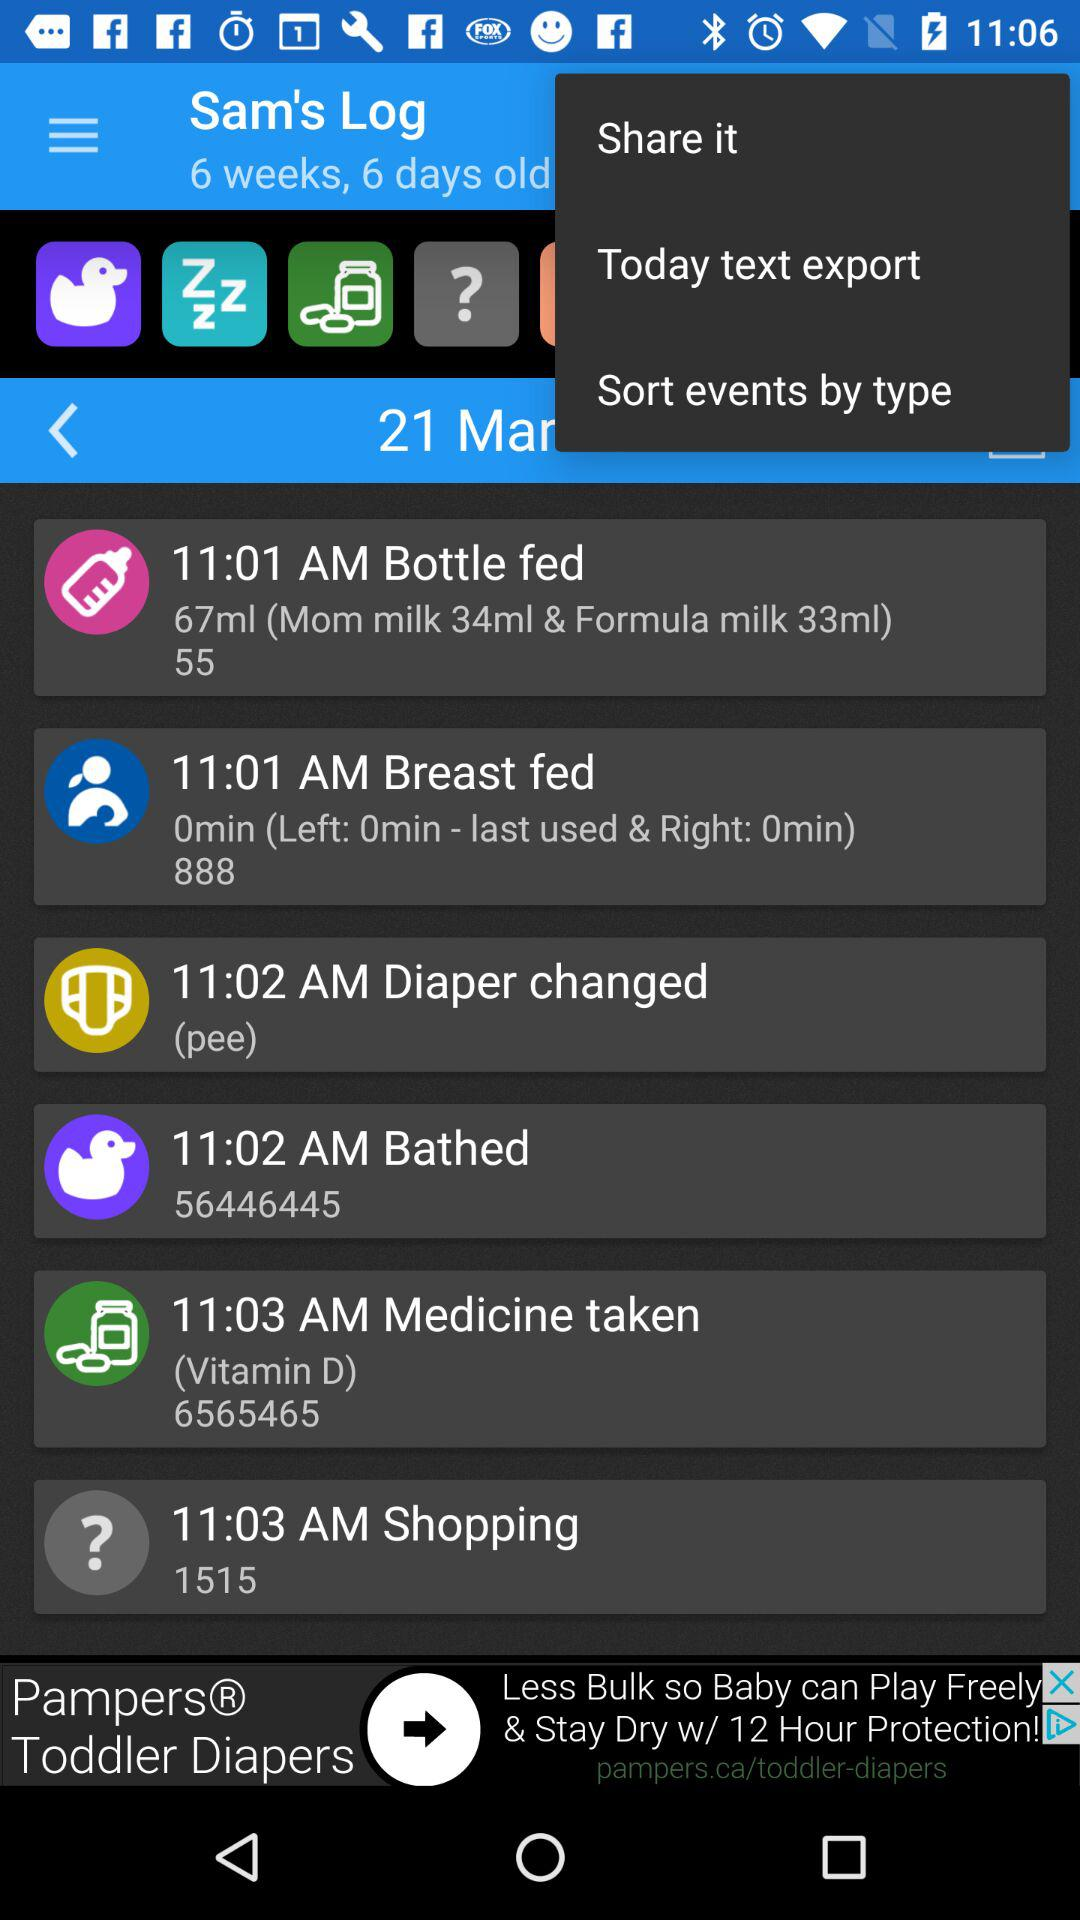How many events are there in the log?
Answer the question using a single word or phrase. 6 